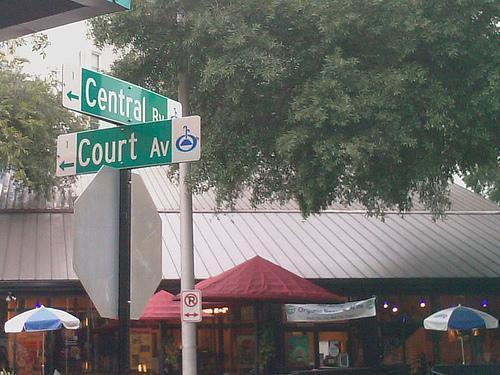How many umbrellas are open?
Give a very brief answer. 4. How many people in the image are wearing black tops?
Give a very brief answer. 0. 